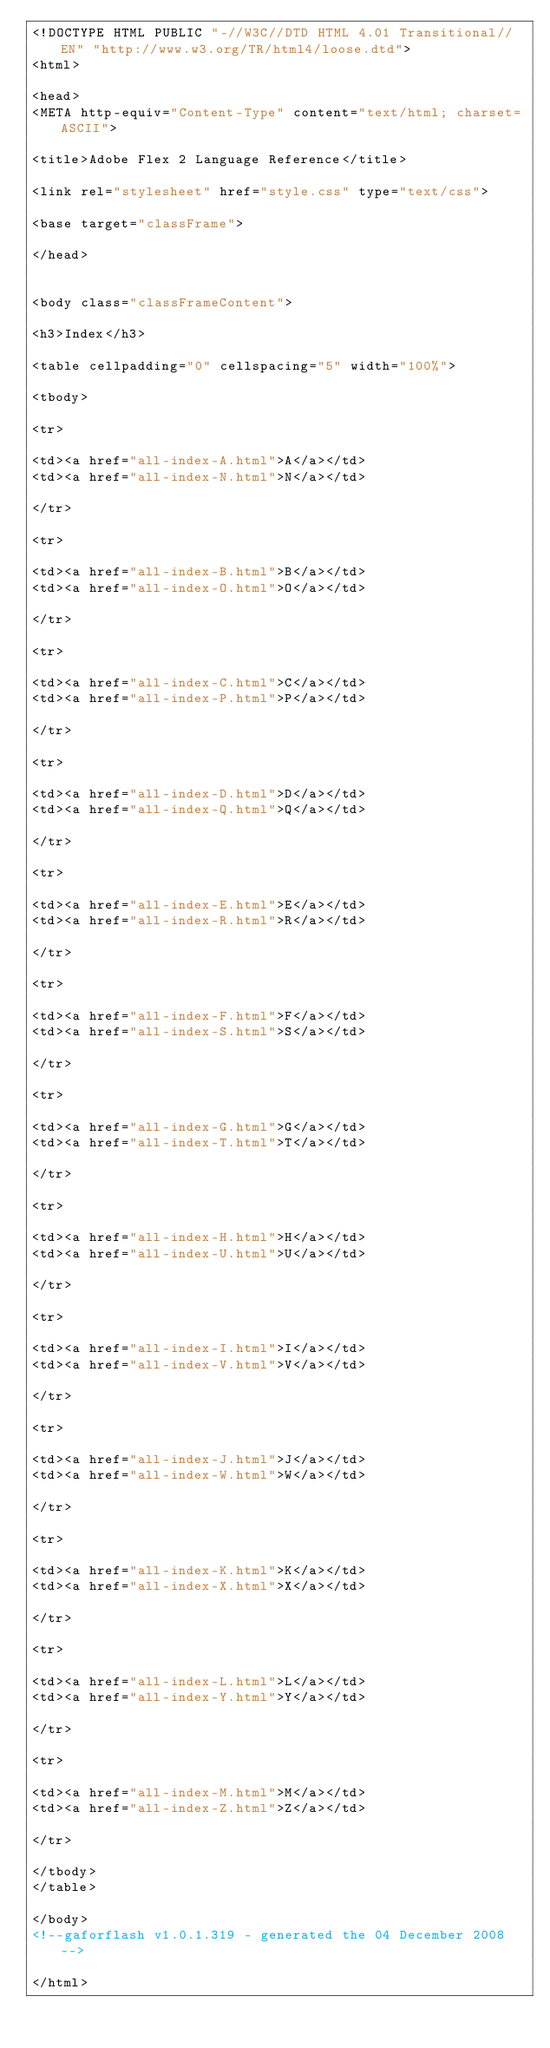Convert code to text. <code><loc_0><loc_0><loc_500><loc_500><_HTML_><!DOCTYPE HTML PUBLIC "-//W3C//DTD HTML 4.01 Transitional//EN" "http://www.w3.org/TR/html4/loose.dtd">
<html>

<head>
<META http-equiv="Content-Type" content="text/html; charset=ASCII">
	
<title>Adobe Flex 2 Language Reference</title>
	
<link rel="stylesheet" href="style.css" type="text/css">
	
<base target="classFrame">

</head>


<body class="classFrameContent">

<h3>Index</h3>

<table cellpadding="0" cellspacing="5" width="100%">

<tbody>

<tr>

<td><a href="all-index-A.html">A</a></td>
<td><a href="all-index-N.html">N</a></td>

</tr>

<tr>

<td><a href="all-index-B.html">B</a></td>
<td><a href="all-index-O.html">O</a></td>

</tr>

<tr>

<td><a href="all-index-C.html">C</a></td>
<td><a href="all-index-P.html">P</a></td>

</tr>

<tr>

<td><a href="all-index-D.html">D</a></td>
<td><a href="all-index-Q.html">Q</a></td>

</tr>

<tr>

<td><a href="all-index-E.html">E</a></td>
<td><a href="all-index-R.html">R</a></td>

</tr>

<tr>

<td><a href="all-index-F.html">F</a></td>
<td><a href="all-index-S.html">S</a></td>

</tr>

<tr>

<td><a href="all-index-G.html">G</a></td>
<td><a href="all-index-T.html">T</a></td>

</tr>

<tr>

<td><a href="all-index-H.html">H</a></td>
<td><a href="all-index-U.html">U</a></td>

</tr>

<tr>

<td><a href="all-index-I.html">I</a></td>
<td><a href="all-index-V.html">V</a></td>

</tr>

<tr>

<td><a href="all-index-J.html">J</a></td>
<td><a href="all-index-W.html">W</a></td>

</tr>

<tr>

<td><a href="all-index-K.html">K</a></td>
<td><a href="all-index-X.html">X</a></td>

</tr>

<tr>

<td><a href="all-index-L.html">L</a></td>
<td><a href="all-index-Y.html">Y</a></td>

</tr>

<tr>

<td><a href="all-index-M.html">M</a></td>
<td><a href="all-index-Z.html">Z</a></td>

</tr>

</tbody>
</table>

</body>
<!--gaforflash v1.0.1.319 - generated the 04 December 2008-->

</html>
</code> 